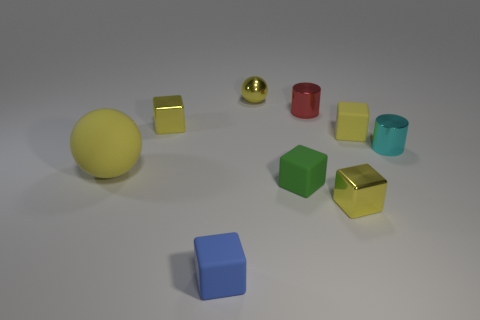Subtract all brown cylinders. How many yellow cubes are left? 3 Subtract 1 blocks. How many blocks are left? 4 Subtract all green cubes. How many cubes are left? 4 Subtract all small green matte blocks. How many blocks are left? 4 Subtract all gray cubes. Subtract all gray cylinders. How many cubes are left? 5 Subtract all blocks. How many objects are left? 4 Add 2 tiny green things. How many tiny green things are left? 3 Add 6 tiny rubber objects. How many tiny rubber objects exist? 9 Subtract 1 cyan cylinders. How many objects are left? 8 Subtract all large yellow metallic cylinders. Subtract all yellow rubber blocks. How many objects are left? 8 